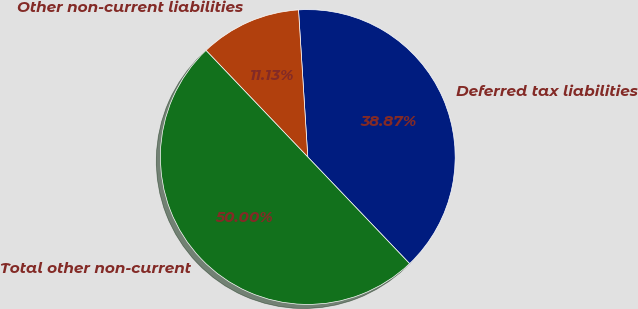Convert chart. <chart><loc_0><loc_0><loc_500><loc_500><pie_chart><fcel>Deferred tax liabilities<fcel>Other non-current liabilities<fcel>Total other non-current<nl><fcel>38.87%<fcel>11.13%<fcel>50.0%<nl></chart> 